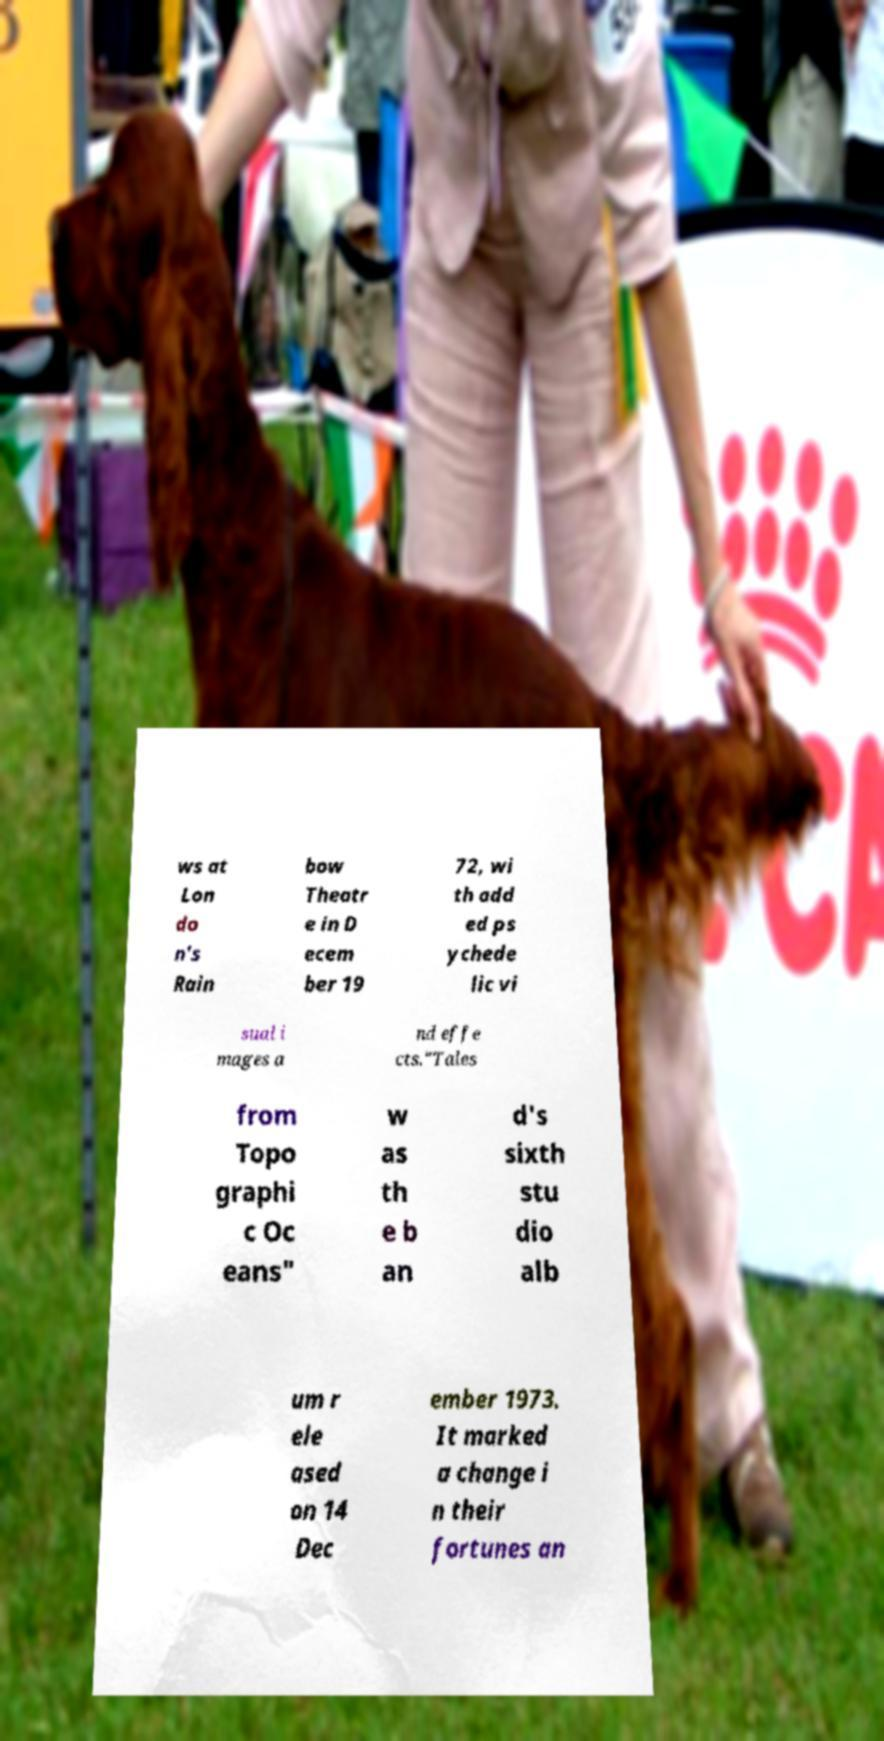Could you extract and type out the text from this image? ws at Lon do n's Rain bow Theatr e in D ecem ber 19 72, wi th add ed ps ychede lic vi sual i mages a nd effe cts."Tales from Topo graphi c Oc eans" w as th e b an d's sixth stu dio alb um r ele ased on 14 Dec ember 1973. It marked a change i n their fortunes an 